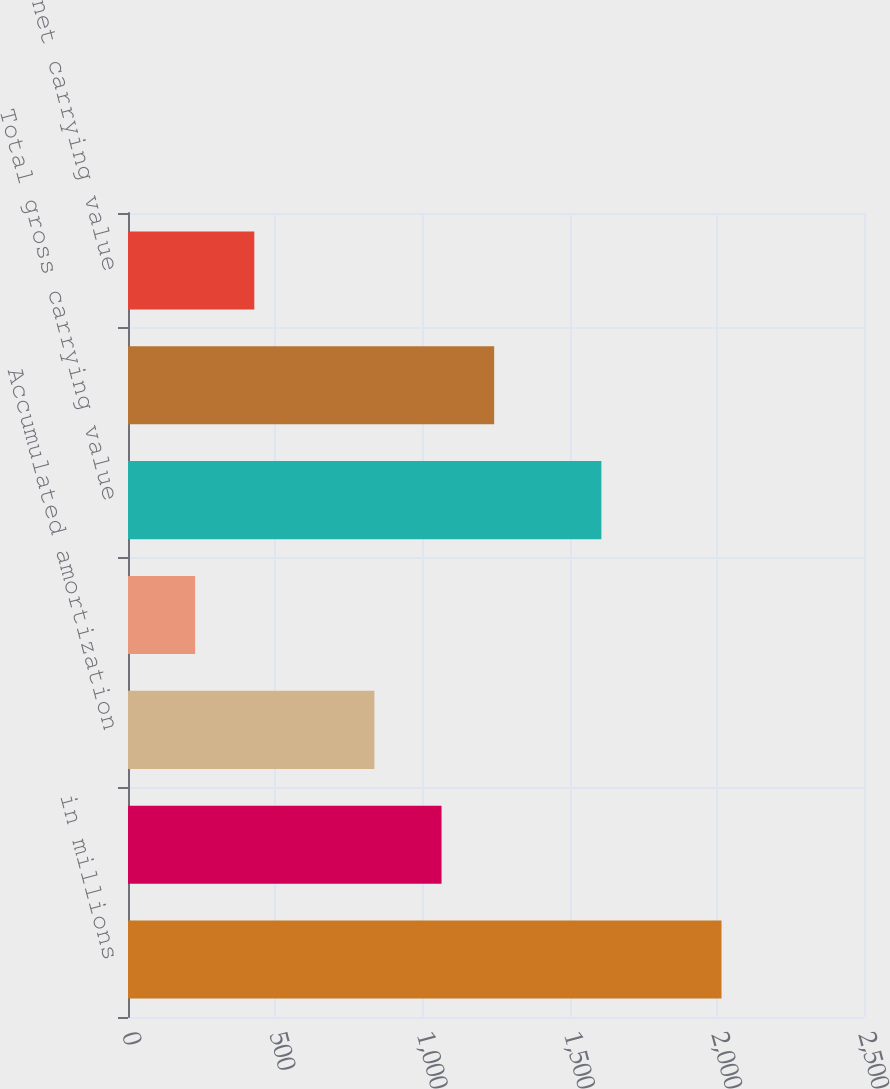<chart> <loc_0><loc_0><loc_500><loc_500><bar_chart><fcel>in millions<fcel>Gross carrying value<fcel>Accumulated amortization<fcel>Net carrying value<fcel>Total gross carrying value<fcel>Total accumulated amortization<fcel>Total net carrying value<nl><fcel>2016<fcel>1065<fcel>837<fcel>228<fcel>1608<fcel>1243.8<fcel>429<nl></chart> 